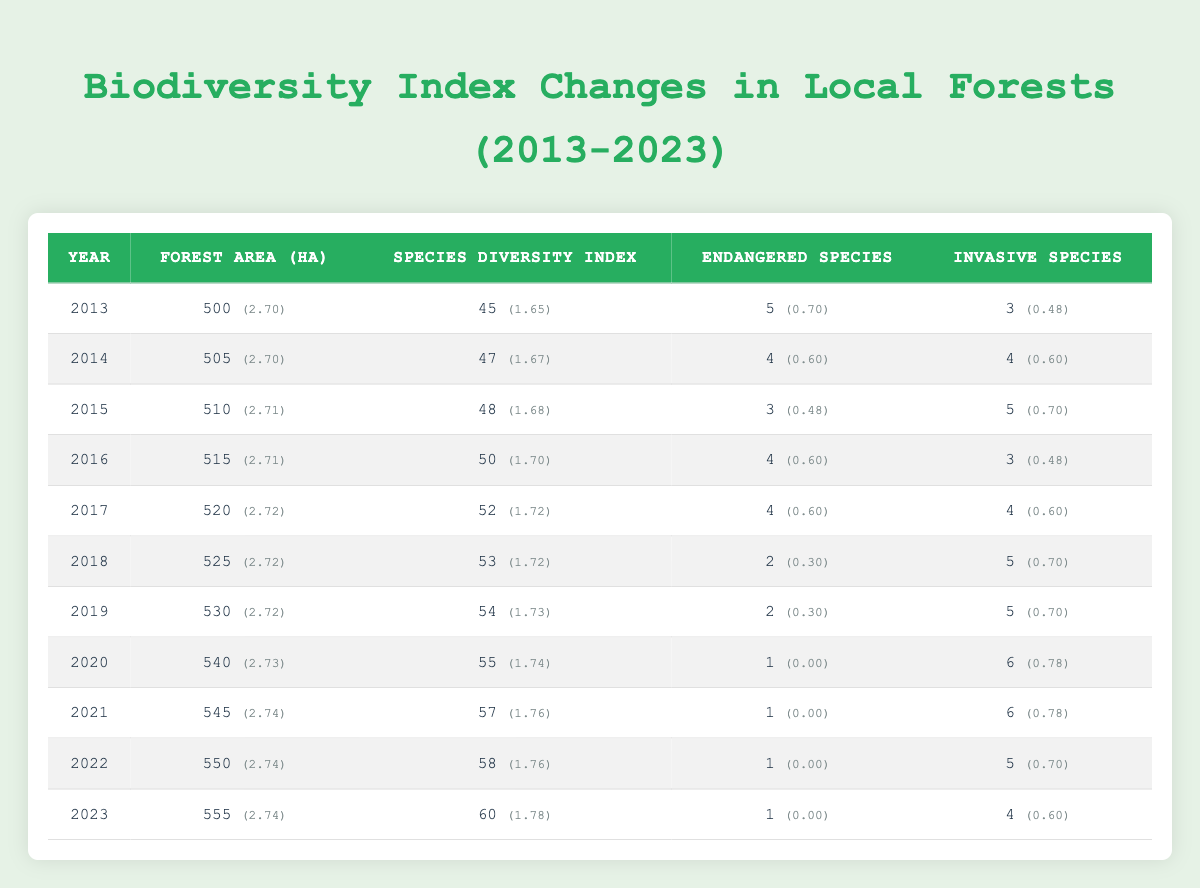What was the species diversity index in 2020? The table indicates that for the year 2020, the species diversity index is 55
Answer: 55 In which year did the number of endangered species first drop below 2? According to the table, the year 2020 marks the first instance where the number of endangered species is 1, which is below 2
Answer: 2020 What is the average species diversity index from 2013 to 2023? To calculate the average, sum the species diversity index from 2013 (45), 2014 (47), 2015 (48), 2016 (50), 2017 (52), 2018 (53), 2019 (54), 2020 (55), 2021 (57), 2022 (58), and 2023 (60). The total is 605, and there are 11 years, so the average is 605/11 = 55
Answer: 55 Did the forest area increase every year from 2013 to 2023? By reviewing the forest area for each year, it’s clear that the forest area increased every year from 2013 (500 ha) to 2023 (555 ha), confirming a consistent upward trend
Answer: Yes In which year was the highest number of invasive species recorded? Examining the table, the highest count of invasive species was recorded in 2020 and 2021, where both years show 6 invasive species
Answer: 2020 and 2021 What are the changes in the number of endangered species from 2013 to 2023? The number of endangered species decreased from 5 in 2013 to 1 in 2023, showing a decline over the years. Specifically, we observe 5, 4, 3, 4, 4, 2, 2, 1, 1, 1, 1 over the years
Answer: Decreased from 5 to 1 How did the species diversity index change between 2013 and 2023? The species diversity index grew from 45 in 2013 to 60 in 2023, indicating an increase of 15 over the ten-year span. The yearly progression is as follows: 45, 47, 48, 50, 52, 53, 54, 55, 57, 58, 60
Answer: Increased by 15 Was there a year where the number of endangered species was the same as the number of invasive species? The table shows that in 2021 and 2022, the number of both endangered and invasive species was both 1 and 5 respectively, indicating that there was no year where they were equal. Hence, the answer is no
Answer: No What is the trend observed in the species diversity index between 2018 and 2023? The data shows a steady increase in the species diversity index during these years: starting from 53 in 2018 and growing each year to reach 60 in 2023, demonstrating a positive trend
Answer: Positive trend 